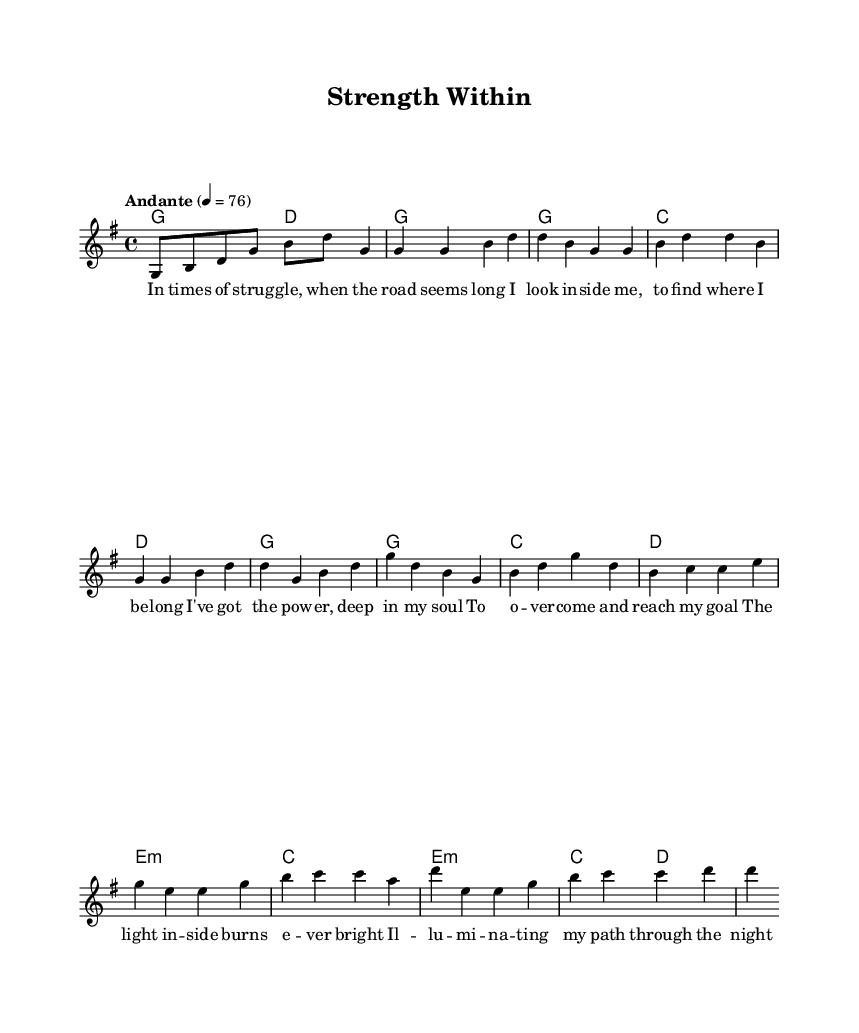What is the key signature of this music? The key signature is G major, which contains one sharp (F#). This can be determined by the presence of the sharp notation next to the treble clef in the music sheet.
Answer: G major What is the time signature of this music? The time signature is 4/4, indicating that there are four beats in each measure and the quarter note receives one beat. This can be identified at the beginning of the score, right after the clef.
Answer: 4/4 What is the tempo marking for this piece? The tempo marking is "Andante," which indicates a moderate pace. This is indicated above the staff at the beginning of the score, along with the metronome marking of 76 beats per minute.
Answer: Andante How many measures are in the verse section? The verse section consists of 4 measures, as indicated by the number of measure bars in the melody. You can count the measures starting from the first verse line to the end of the verse section.
Answer: 4 Which chord is used in the bridge section? The bridge section begins with an E minor chord, as indicated by the use of "e1:m" in the harmonies. This indicates that the chord played in that measure is an E minor.
Answer: E minor What reinforces the theme of perseverance in the chorus lyrics? The phrase "I've got the power, deep in my soul" reinforces the theme of inner strength and perseverance. This is a direct reference to the spiritual aspect and determination reflected through the lyrics.
Answer: I've got the power What is the ending dynamic marking for the bridge section? There is no specific dynamic marking indicated at the end of the bridge section within the provided data. It’s common for spirituals to allow for dynamic fluctuations based on emotional delivery, but the sheet music does not specify it.
Answer: None specified 